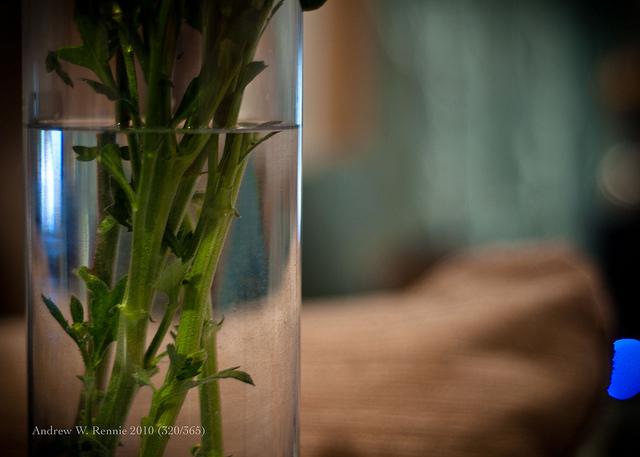How many bases are on the shelf?
Answer briefly. 1. What is in the vase?
Answer briefly. Plant. Is there spilled alcohol?
Answer briefly. No. Do the flowers need water?
Write a very short answer. No. What color is the vases?
Short answer required. Clear. What shapes are on the mug on the left?
Short answer required. Circular. What color is the vase?
Concise answer only. Clear. How many limbs are shown?
Keep it brief. 0. What color is the dot to the right side?
Be succinct. Blue. How many flowers are in the vase?
Short answer required. 4. Are these flower stems?
Concise answer only. Yes. 